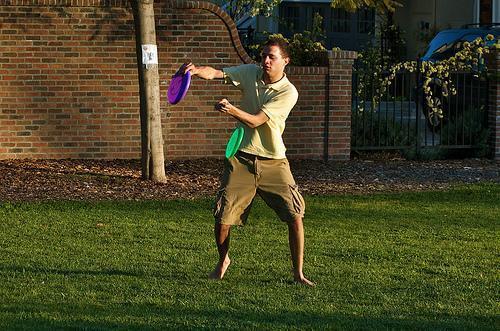How many frisbees are there?
Give a very brief answer. 2. How many people are in the picture?
Give a very brief answer. 1. 